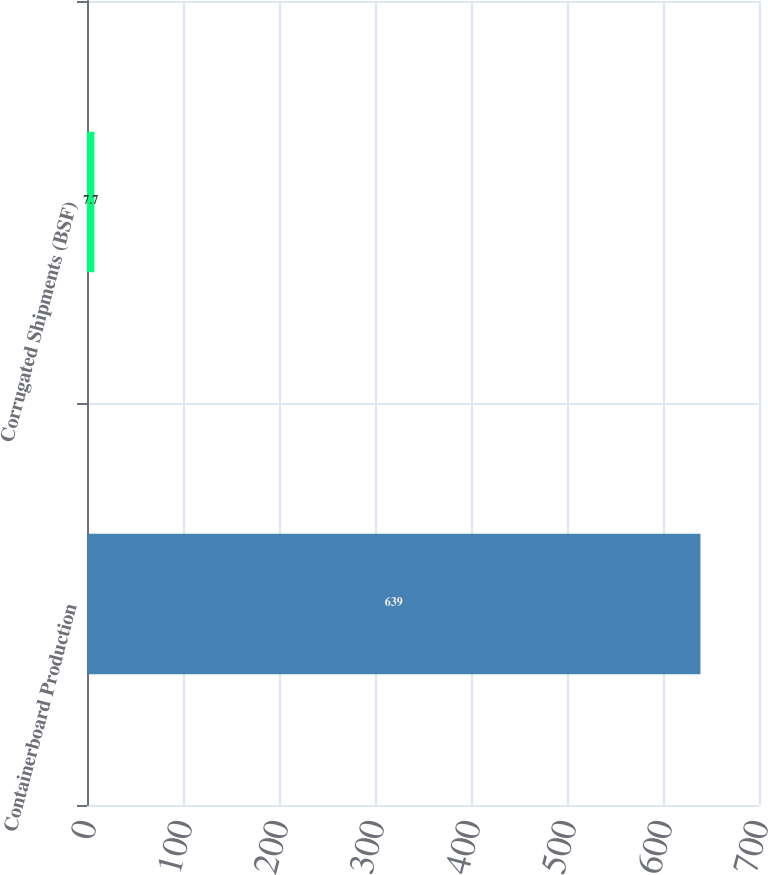Convert chart. <chart><loc_0><loc_0><loc_500><loc_500><bar_chart><fcel>Containerboard Production<fcel>Corrugated Shipments (BSF)<nl><fcel>639<fcel>7.7<nl></chart> 